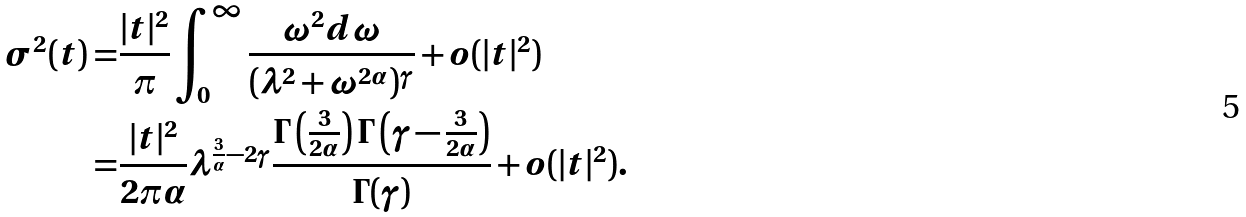<formula> <loc_0><loc_0><loc_500><loc_500>\sigma ^ { 2 } ( t ) = & \frac { | t | ^ { 2 } } { \pi } \int _ { 0 } ^ { \infty } \frac { \omega ^ { 2 } d \omega } { ( \lambda ^ { 2 } + \omega ^ { 2 \alpha } ) ^ { \gamma } } + o ( | t | ^ { 2 } ) \\ = & \frac { | t | ^ { 2 } } { 2 \pi \alpha } \lambda ^ { \frac { 3 } { \alpha } - 2 \gamma } \frac { \Gamma \left ( \frac { 3 } { 2 \alpha } \right ) \Gamma \left ( \gamma - \frac { 3 } { 2 \alpha } \right ) } { \Gamma ( \gamma ) } + o ( | t | ^ { 2 } ) .</formula> 